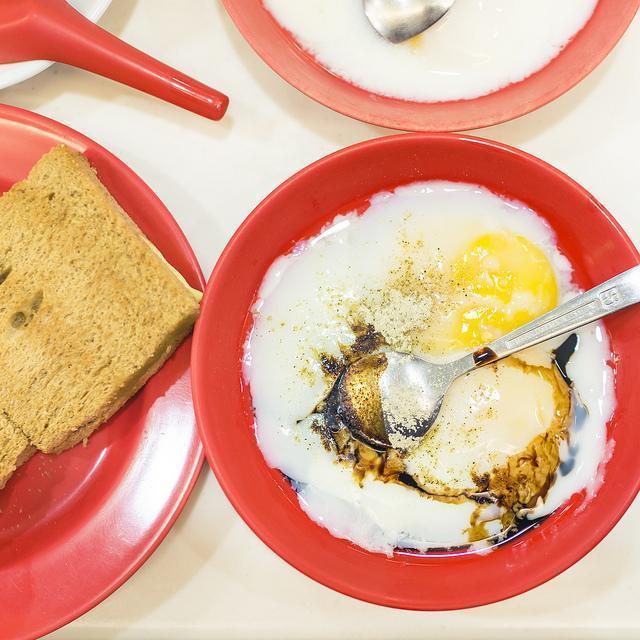Does the image validate the caption "The sandwich is in the bowl."?
Answer yes or no. No. 